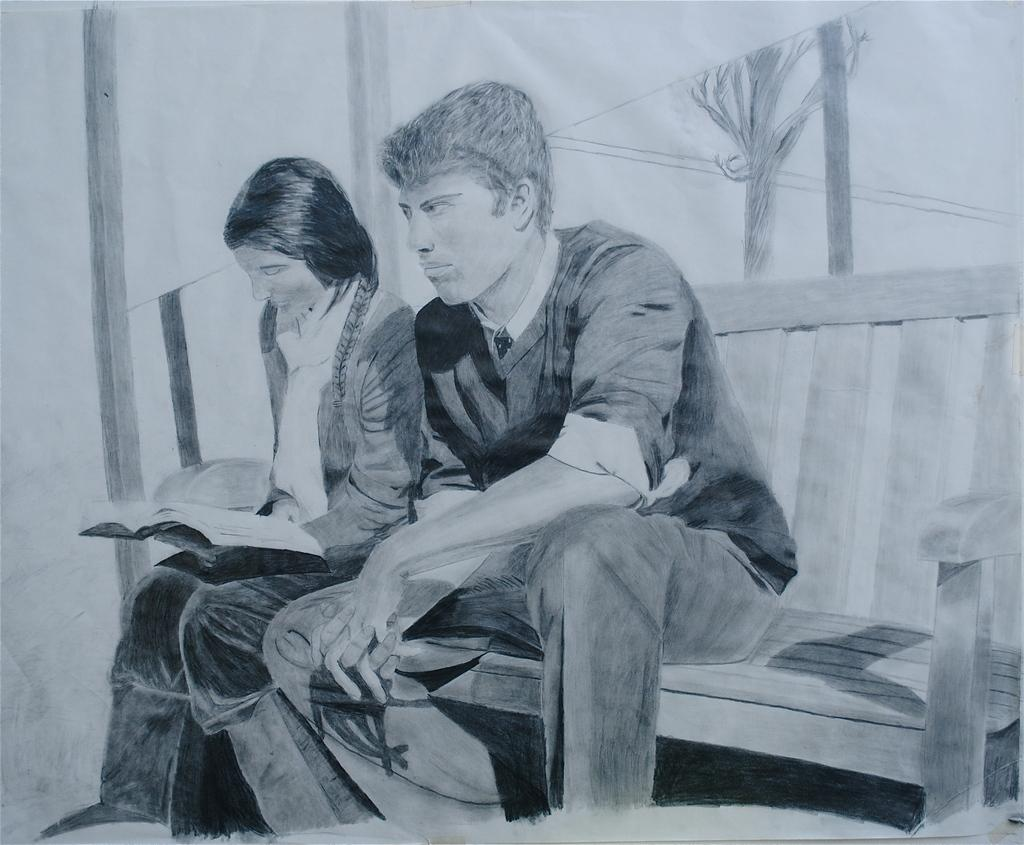What is the medium used for the image? The image is a sketch done on paper with a pencil. What are the subjects in the sketch? There is a man and a woman sitting on a bench in the sketch. What is one of the women doing in the sketch? A woman is reading a book in the sketch. How much money is being exchanged between the man and woman in the sketch? There is no indication of money or any exchange taking place in the sketch. Is the bench located in quicksand in the sketch? There is no quicksand present in the sketch; the bench is on a solid surface. 